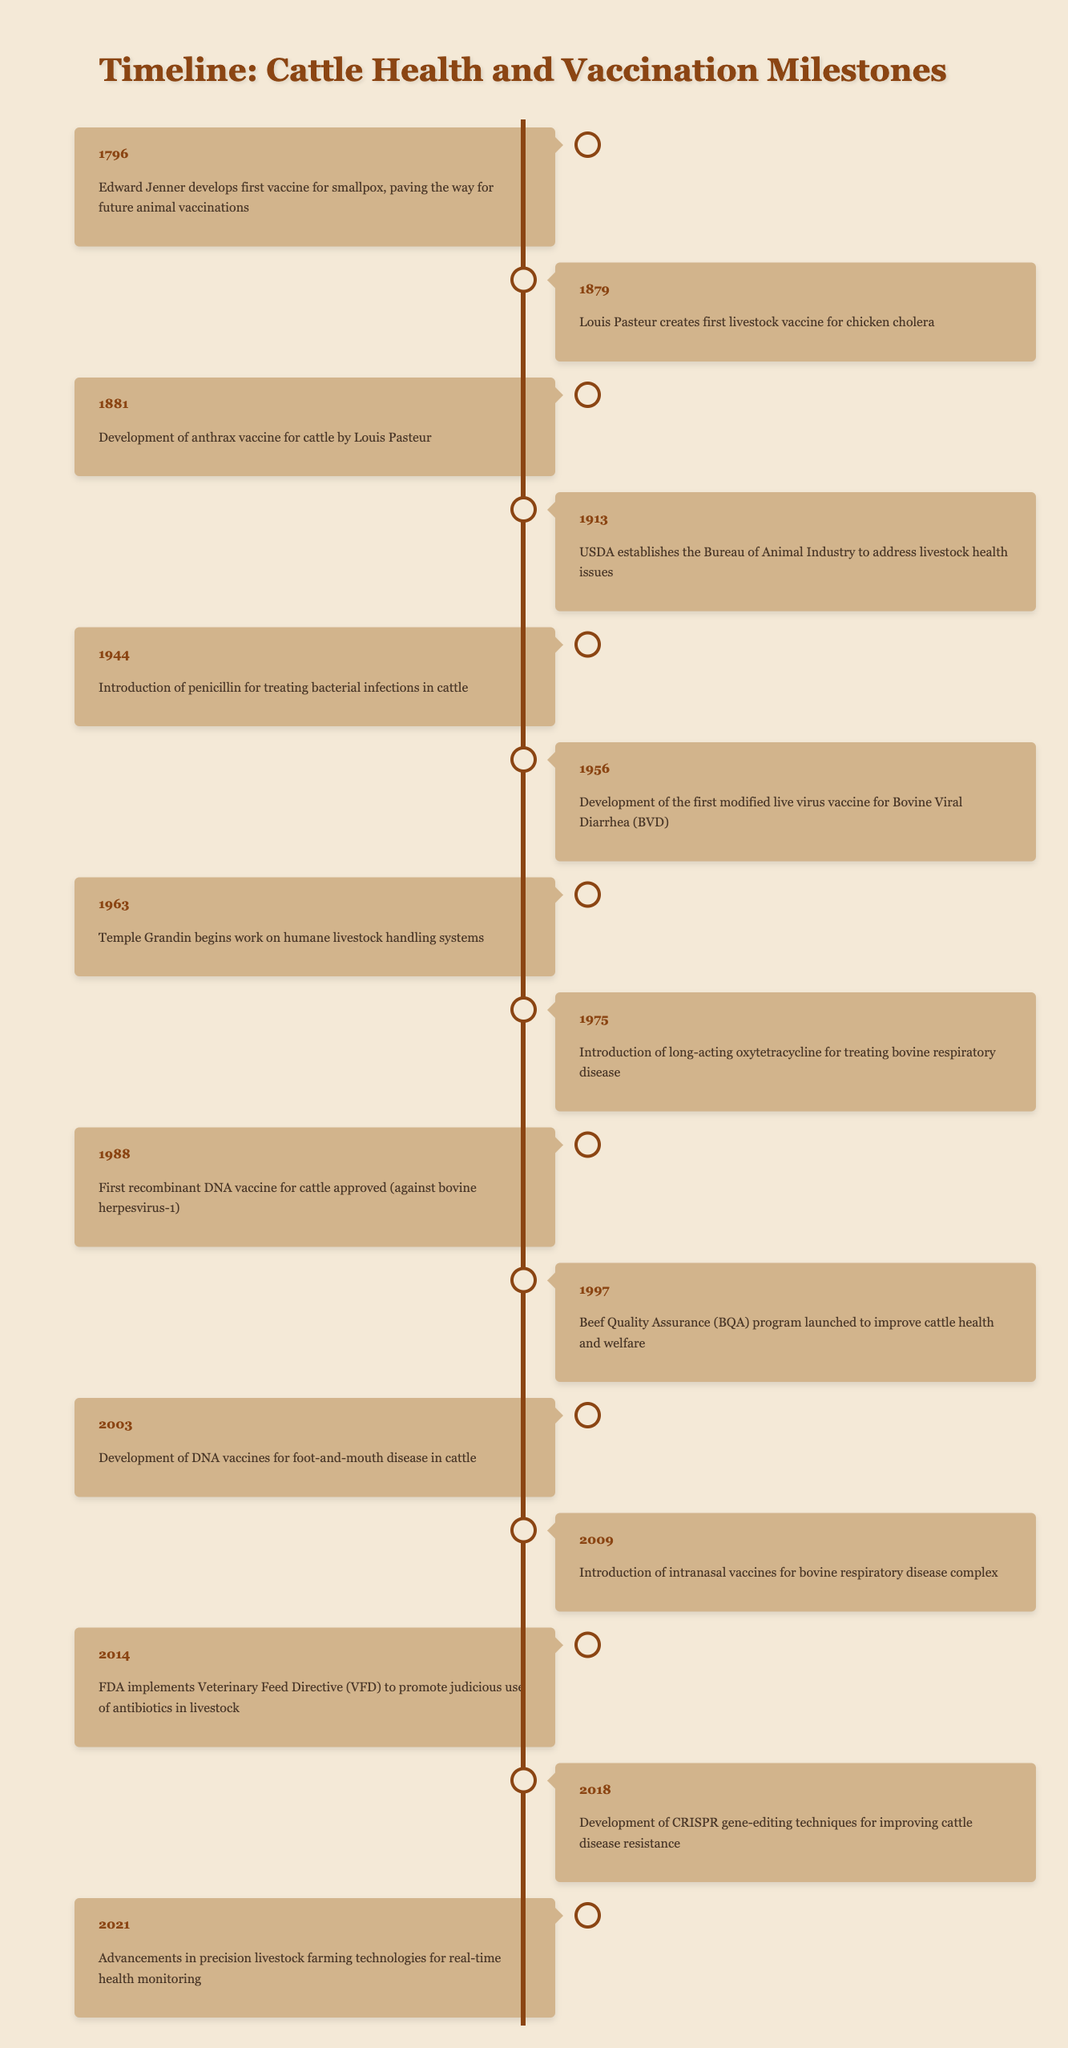What year did Louis Pasteur create the first livestock vaccine? The table indicates that Louis Pasteur created the first livestock vaccine in 1879. To find this information, I look for the event that mentions Louis Pasteur alongside the year.
Answer: 1879 Which event related to livestock health occurred most recently? The most recent year listed in the table is 2021, which corresponds to advancements in precision livestock farming technologies for health monitoring. Therefore, this is the latest event related to livestock health.
Answer: 2021 Was the introduction of penicillin for treating bacterial infections in cattle related to a specific year? According to the table, the introduction of penicillin for treating cattle infections occurred in the year 1944. This is a straightforward retrieval of the event's associated year.
Answer: Yes How many years passed between the development of the anthrax vaccine and the first recombinant DNA vaccine for cattle? The development of the anthrax vaccine occurred in 1881 and the first recombinant DNA vaccine was approved in 1988. The difference is 1988 - 1881 = 107 years. This calculation provides the number of years between these two significant milestones.
Answer: 107 years Is there any event listed for the year 2000? Checking the table for the year 2000 shows that there are no entries for that year. It implies no relevant event in livestock vaccination or health protocols occurred in that year.
Answer: No What was the significance of the Beef Quality Assurance program launched in 1997? The table states that the Beef Quality Assurance program (BQA) was launched in 1997 to improve cattle health and welfare. This event indicates a shift towards better monitoring and protocols for cattle care in that year.
Answer: Improve cattle health and welfare What advancements were made in cattle health protocols between the years 1944 and 2021? Between 1944 and 2021, several key advancements occurred: the introduction of penicillin in 1944, development of modified live virus vaccines in 1956, humane handling systems initiated in 1963, introduction of long-acting oxytetracycline in 1975, establishment of the BQA program in 1997, and advancements in precision livestock farming in 2021. This shows a continuous development over the years in cattle health protocols.
Answer: Several advancements in cattle health occurred What were the first animal vaccination milestones mentioned in the table? The milestones include Edward Jenner's development of the smallpox vaccine in 1796, and Louis Pasteur's creation of the chicken cholera vaccine in 1879. This highlights the early historical context for animal vaccinations leading up to cattle-specific vaccines.
Answer: Smallpox and chicken cholera vaccines 